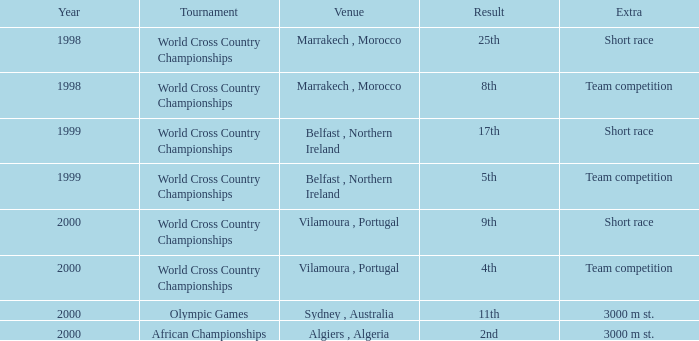Tell me the highest year for result of 9th 2000.0. 